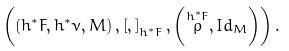<formula> <loc_0><loc_0><loc_500><loc_500>\left ( \left ( h ^ { \ast } F , h ^ { \ast } \nu , M \right ) , \left [ , \right ] _ { h ^ { \ast } F } , \left ( \overset { h ^ { \ast } F } { \rho } , I d _ { M } \right ) \right ) .</formula> 